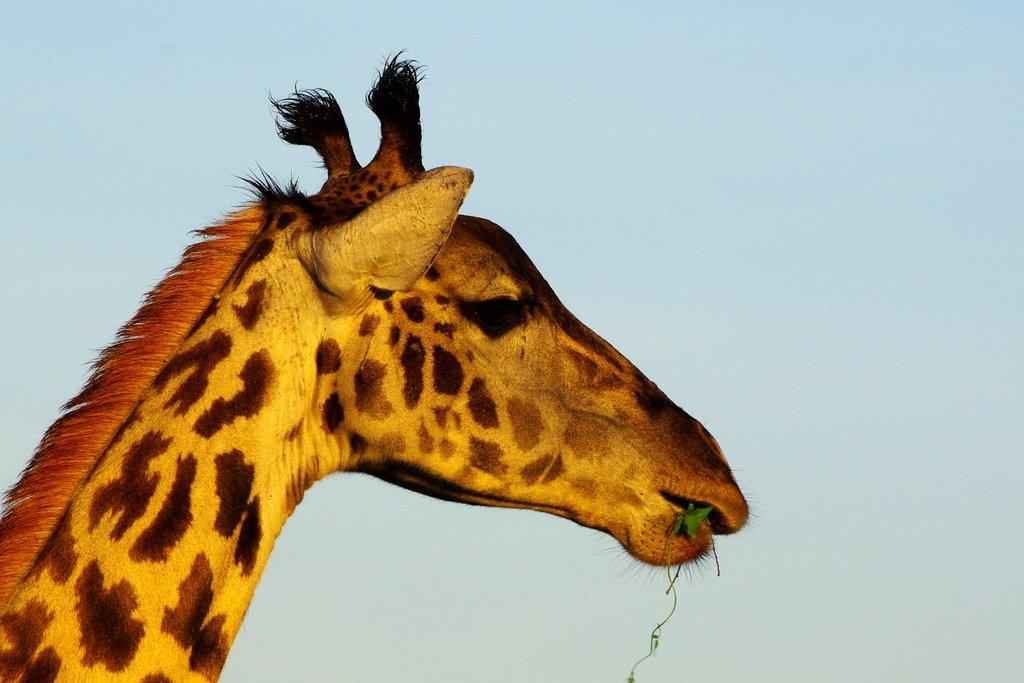What animal is present in the image? There is a giraffe in the image. What is the giraffe doing in the image? The giraffe is eating grass. What can be seen in the background of the image? The sky is visible in the background of the image. What type of fuel is the giraffe using to power its movements in the image? The giraffe is not using any fuel to power its movements in the image; it is eating grass. Can you see a wristwatch on the giraffe in the image? There is no wristwatch or any other accessory visible on the giraffe in the image. 